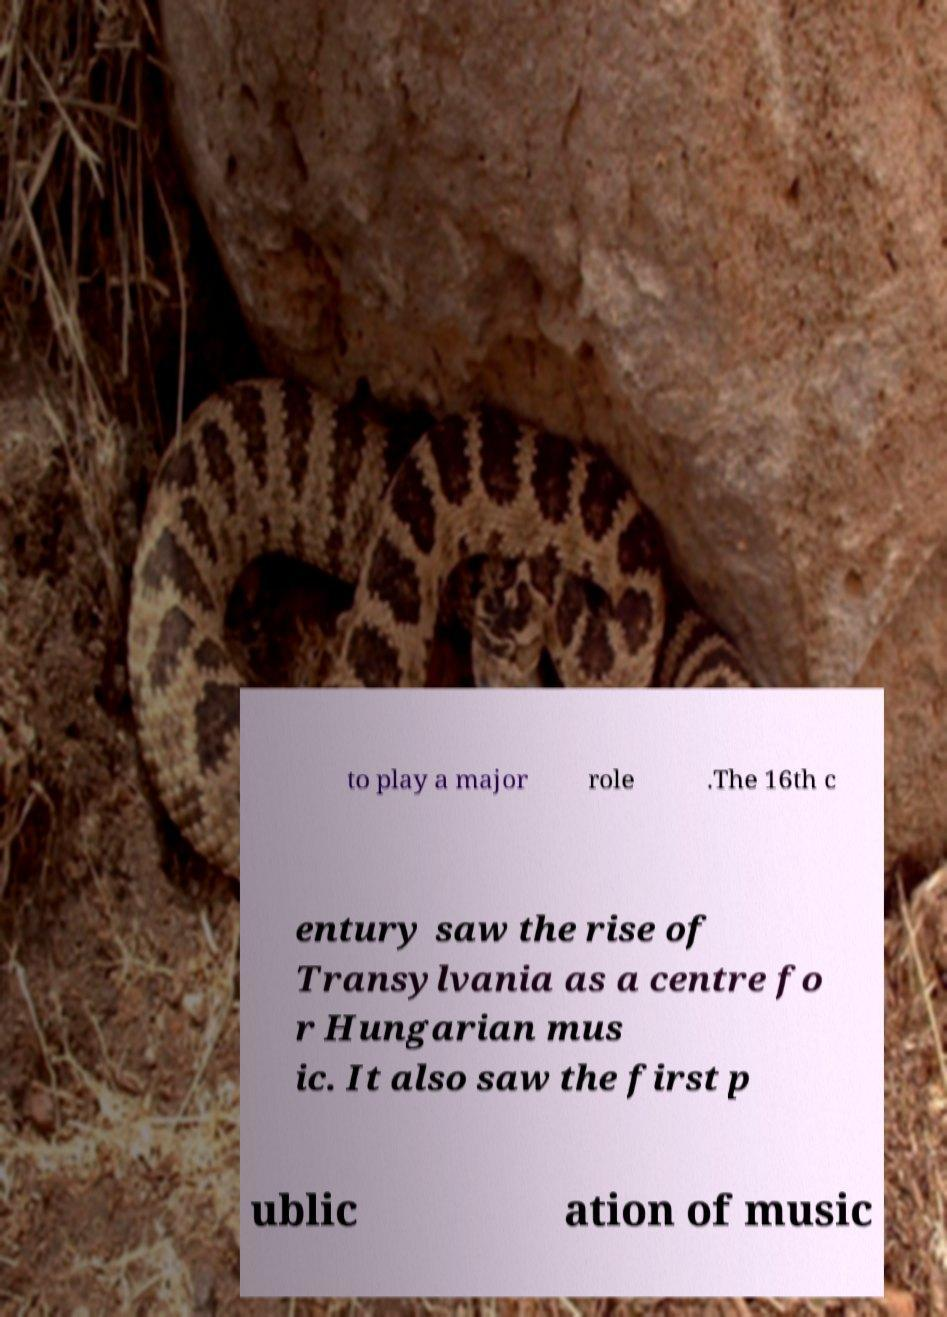There's text embedded in this image that I need extracted. Can you transcribe it verbatim? to play a major role .The 16th c entury saw the rise of Transylvania as a centre fo r Hungarian mus ic. It also saw the first p ublic ation of music 